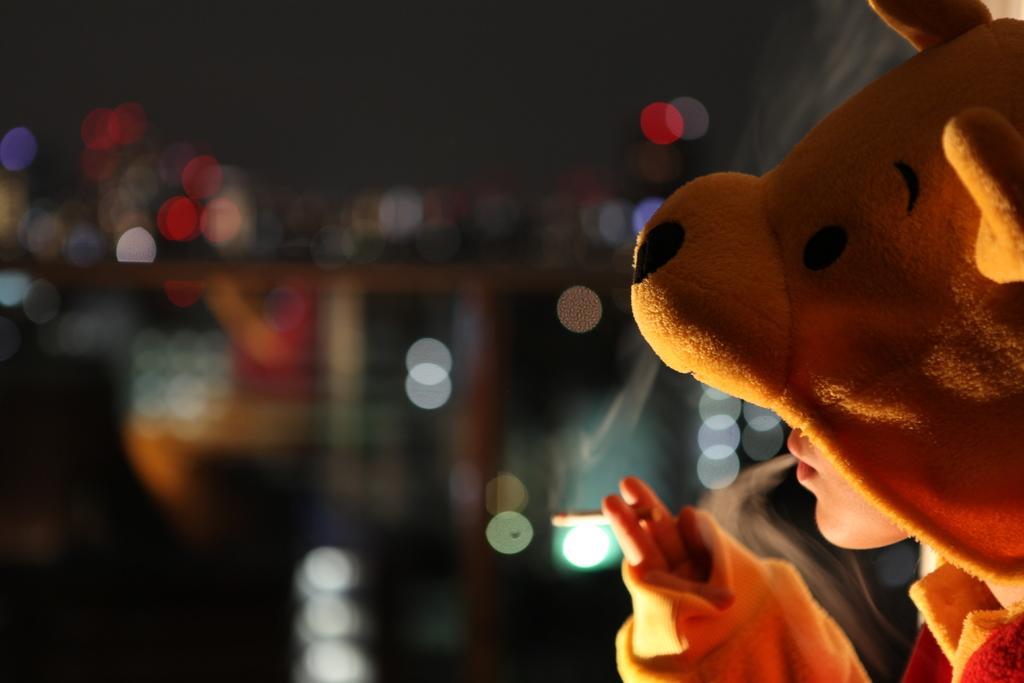How would you summarize this image in a sentence or two? In this image there is one person is wearing teddy bear dress at right side of this image. 